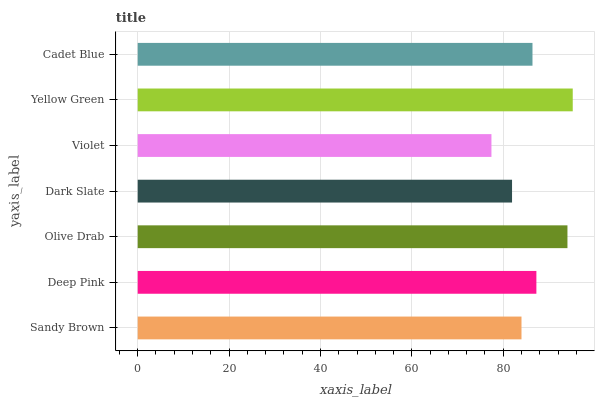Is Violet the minimum?
Answer yes or no. Yes. Is Yellow Green the maximum?
Answer yes or no. Yes. Is Deep Pink the minimum?
Answer yes or no. No. Is Deep Pink the maximum?
Answer yes or no. No. Is Deep Pink greater than Sandy Brown?
Answer yes or no. Yes. Is Sandy Brown less than Deep Pink?
Answer yes or no. Yes. Is Sandy Brown greater than Deep Pink?
Answer yes or no. No. Is Deep Pink less than Sandy Brown?
Answer yes or no. No. Is Cadet Blue the high median?
Answer yes or no. Yes. Is Cadet Blue the low median?
Answer yes or no. Yes. Is Violet the high median?
Answer yes or no. No. Is Dark Slate the low median?
Answer yes or no. No. 